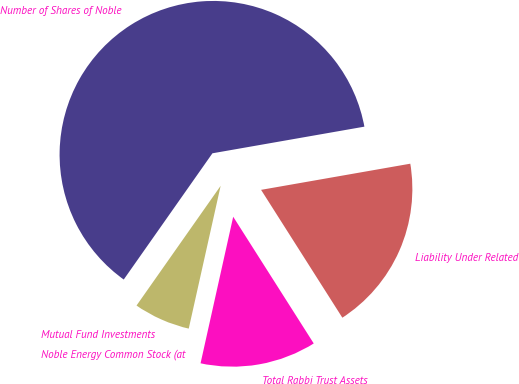<chart> <loc_0><loc_0><loc_500><loc_500><pie_chart><fcel>Mutual Fund Investments<fcel>Noble Energy Common Stock (at<fcel>Total Rabbi Trust Assets<fcel>Liability Under Related<fcel>Number of Shares of Noble<nl><fcel>6.25%<fcel>0.01%<fcel>12.5%<fcel>18.75%<fcel>62.49%<nl></chart> 